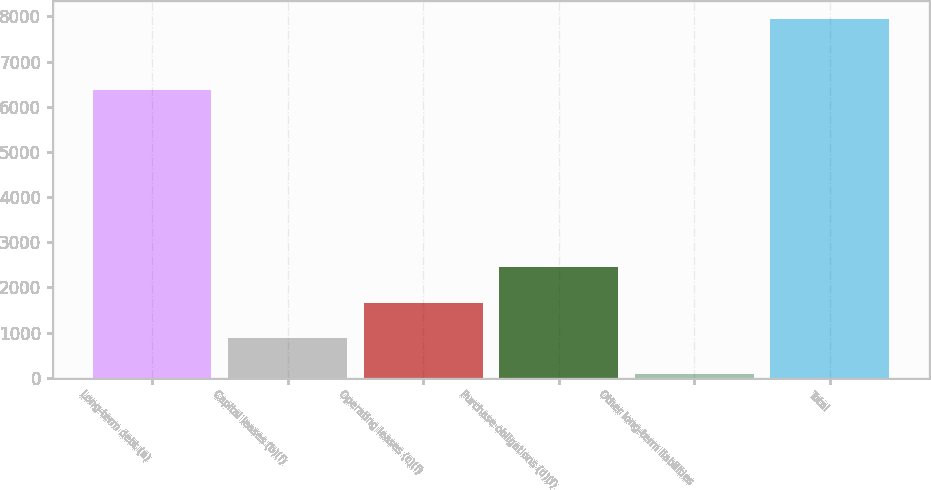Convert chart to OTSL. <chart><loc_0><loc_0><loc_500><loc_500><bar_chart><fcel>Long-term debt (a)<fcel>Capital leases (b)(f)<fcel>Operating leases (c)(f)<fcel>Purchase obligations (d)(f)<fcel>Other long-term liabilities<fcel>Total<nl><fcel>6369<fcel>870.1<fcel>1657.2<fcel>2444.3<fcel>83<fcel>7954<nl></chart> 